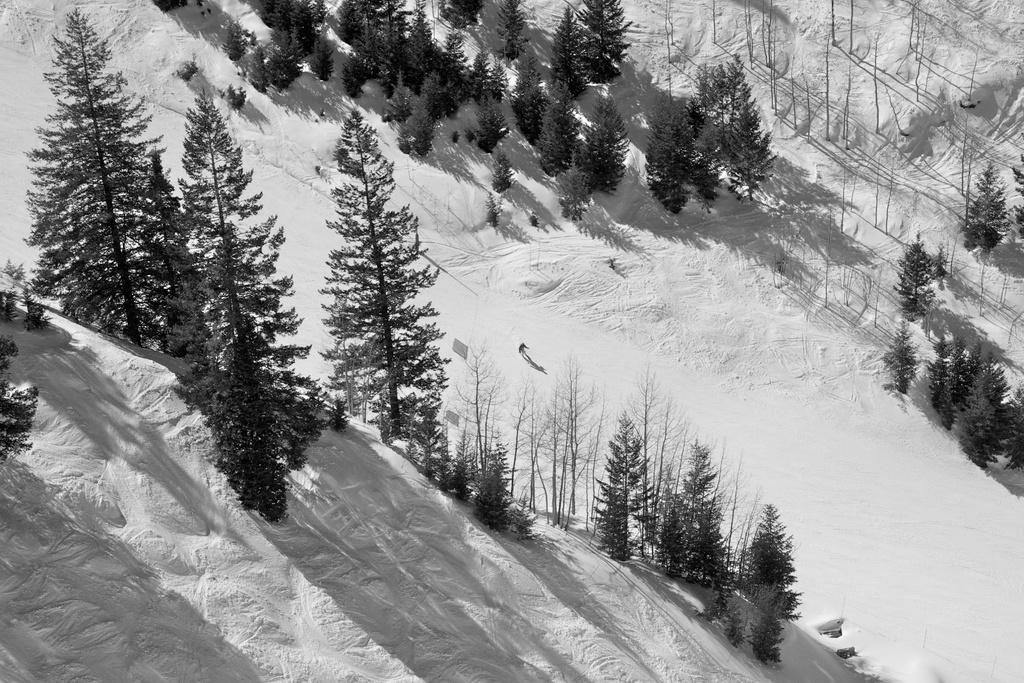What is the color scheme of the image? The image is black and white. What can be seen in the background of the image? There is a group of trees in the image. What is the person in the image doing? The person is standing in the snow in the center of the image. What type of jeans is the person wearing in the image? There is no information about the person's clothing in the image, as it is black and white and does not provide details about the person's attire. 